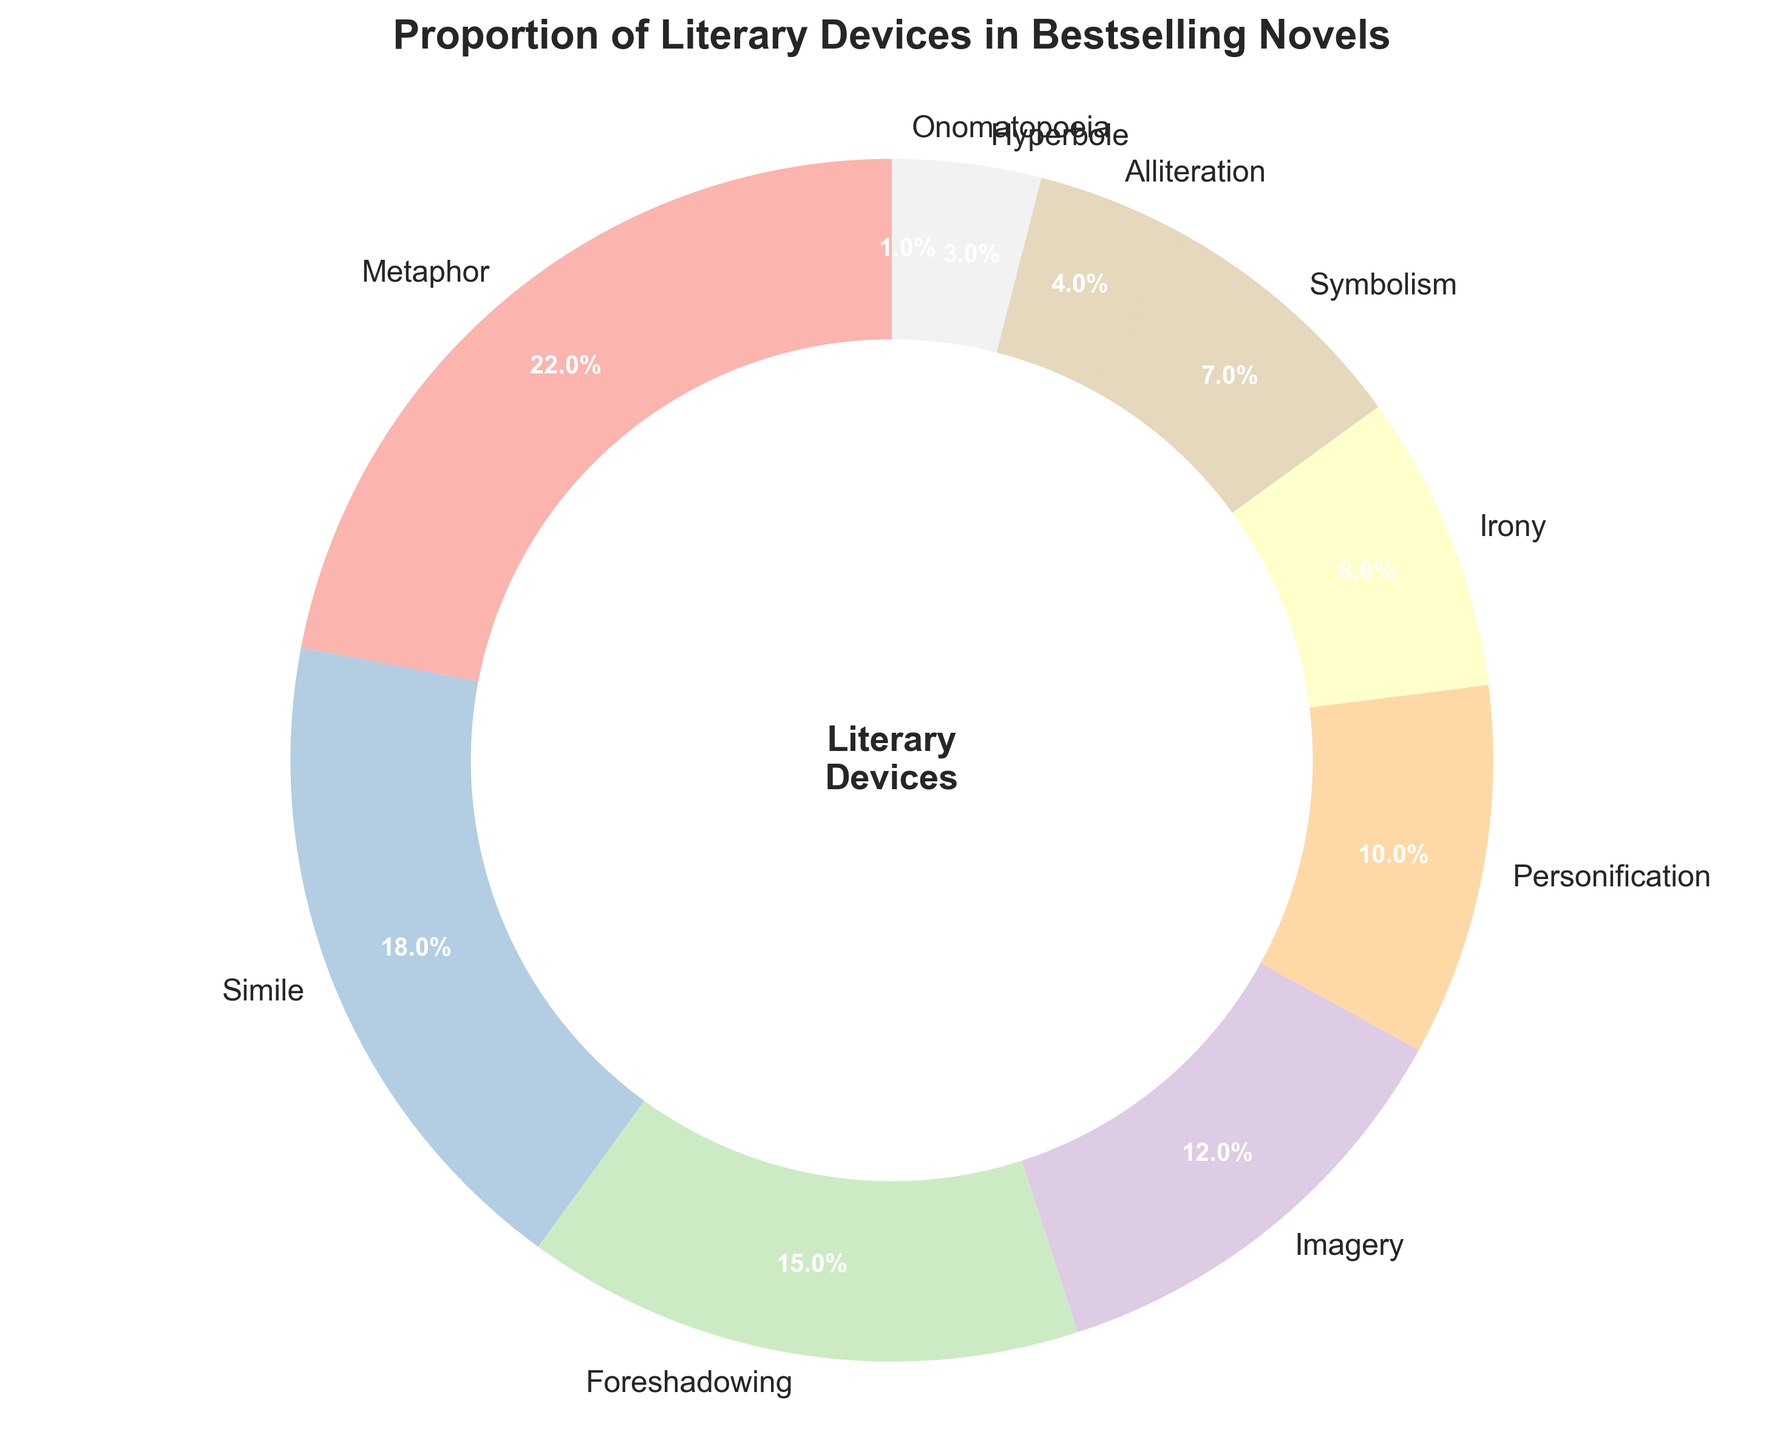Which literary device has the highest percentage in bestselling novels? To determine which device has the highest percentage, look for the highest value on the chart. Metaphor has the highest percentage at 22%.
Answer: Metaphor What is the combined percentage of Metaphor and Simile? First, identify the percentages for Metaphor and Simile. Then add these values: 22% (Metaphor) + 18% (Simile) = 40%.
Answer: 40% Which literary device has the second lowest percentage? Identify the percentages of all devices and rank them. Onomatopoeia is the lowest at 1%, and Hyperbole is the second lowest at 3%.
Answer: Hyperbole How many literary devices have a percentage greater than 10%? Count the devices with percentages showing more than 10%: Metaphor (22%), Simile (18%), Foreshadowing (15%), and Imagery (12%) have percentages greater than 10%.
Answer: 4 Is the percentage of Personification more or less than half the percentage of Metaphor? Compare half of Metaphor's percentage (22% / 2 = 11%) with Personification's percentage (10%). Since 10% is less than 11%, Personification’s percentage is less than half of Metaphor’s.
Answer: Less What is the difference in percentage between Irony and Symbolism? Identify the percentages for Irony (8%) and Symbolism (7%). Then find the difference: 8% - 7% = 1%.
Answer: 1% Which literary device takes up the largest segment of the pie chart? Identify the largest segment visually, which corresponds to the highest percentage. Metaphor, at 22%, has the largest segment.
Answer: Metaphor What percentage do Imagery and Personification contribute together? Add the percentages of Imagery (12%) and Personification (10%): 12% + 10% = 22%.
Answer: 22% Which literary device is represented by the smallest segment of the pie chart? Look for the smallest segment visually, which corresponds to the lowest percentage. Onomatopoeia, at 1%, has the smallest segment.
Answer: Onomatopoeia Are there more literary devices with a percentage below 10% or above 10%? Count the devices below and above 10%. Below 10%: Irony (8%), Symbolism (7%), Alliteration (4%), Hyperbole (3%), Onomatopoeia (1%) = 5 devices. Above 10%: Metaphor (22%), Simile (18%), Foreshadowing (15%), Imagery (12%) = 4 devices. There are more devices below 10%.
Answer: Below 10% 